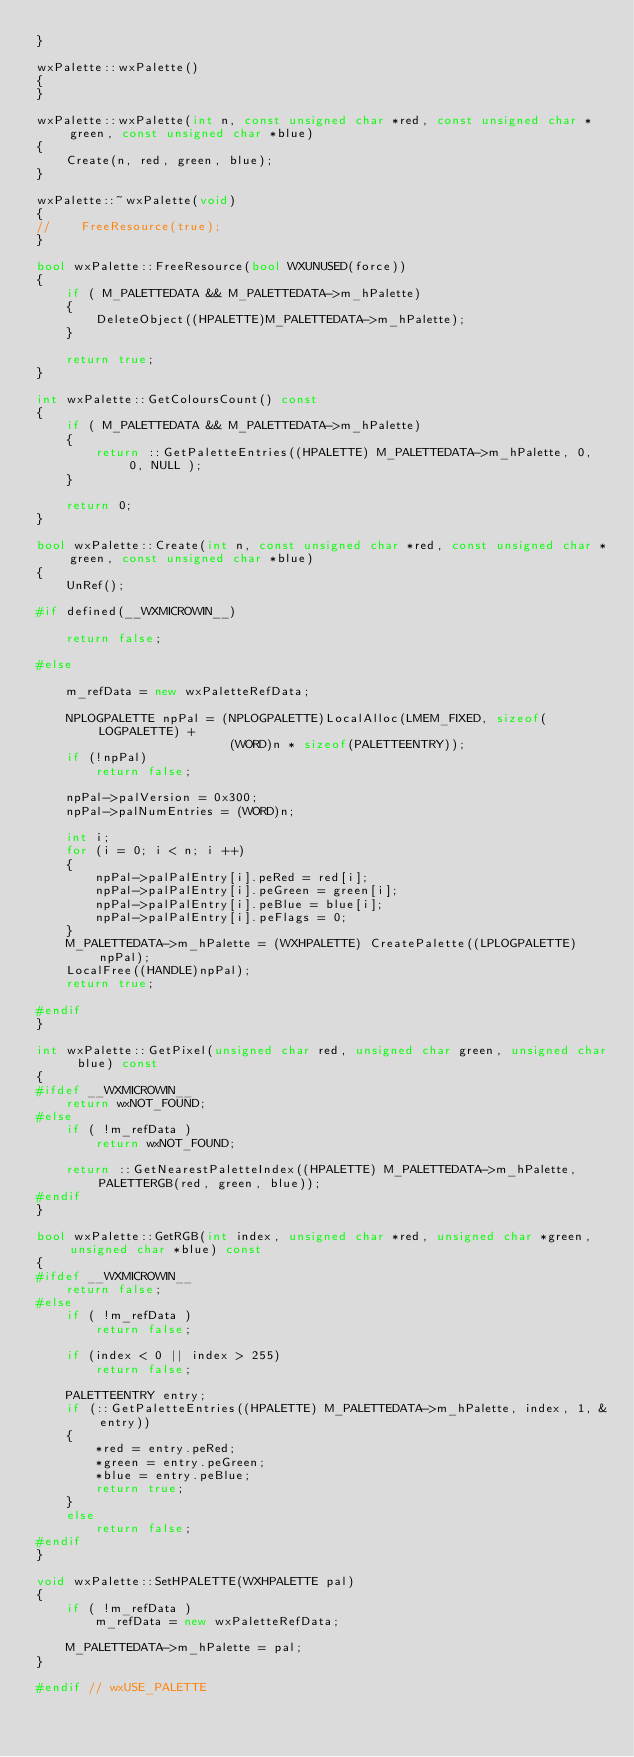<code> <loc_0><loc_0><loc_500><loc_500><_C++_>}

wxPalette::wxPalette()
{
}

wxPalette::wxPalette(int n, const unsigned char *red, const unsigned char *green, const unsigned char *blue)
{
    Create(n, red, green, blue);
}

wxPalette::~wxPalette(void)
{
//    FreeResource(true);
}

bool wxPalette::FreeResource(bool WXUNUSED(force))
{
    if ( M_PALETTEDATA && M_PALETTEDATA->m_hPalette)
    {
        DeleteObject((HPALETTE)M_PALETTEDATA->m_hPalette);
    }
    
    return true;
}

int wxPalette::GetColoursCount() const
{
    if ( M_PALETTEDATA && M_PALETTEDATA->m_hPalette)
    {
        return ::GetPaletteEntries((HPALETTE) M_PALETTEDATA->m_hPalette, 0, 0, NULL );
    }
    
    return 0;
}

bool wxPalette::Create(int n, const unsigned char *red, const unsigned char *green, const unsigned char *blue)
{
    UnRef();

#if defined(__WXMICROWIN__)

    return false;

#else

    m_refData = new wxPaletteRefData;

    NPLOGPALETTE npPal = (NPLOGPALETTE)LocalAlloc(LMEM_FIXED, sizeof(LOGPALETTE) +
                          (WORD)n * sizeof(PALETTEENTRY));
    if (!npPal)
        return false;

    npPal->palVersion = 0x300;
    npPal->palNumEntries = (WORD)n;

    int i;
    for (i = 0; i < n; i ++)
    {
        npPal->palPalEntry[i].peRed = red[i];
        npPal->palPalEntry[i].peGreen = green[i];
        npPal->palPalEntry[i].peBlue = blue[i];
        npPal->palPalEntry[i].peFlags = 0;
    }
    M_PALETTEDATA->m_hPalette = (WXHPALETTE) CreatePalette((LPLOGPALETTE)npPal);
    LocalFree((HANDLE)npPal);
    return true;

#endif
}

int wxPalette::GetPixel(unsigned char red, unsigned char green, unsigned char blue) const
{
#ifdef __WXMICROWIN__
    return wxNOT_FOUND;
#else
    if ( !m_refData )
        return wxNOT_FOUND;

    return ::GetNearestPaletteIndex((HPALETTE) M_PALETTEDATA->m_hPalette, PALETTERGB(red, green, blue));
#endif
}

bool wxPalette::GetRGB(int index, unsigned char *red, unsigned char *green, unsigned char *blue) const
{
#ifdef __WXMICROWIN__
    return false;
#else
    if ( !m_refData )
        return false;

    if (index < 0 || index > 255)
        return false;

    PALETTEENTRY entry;
    if (::GetPaletteEntries((HPALETTE) M_PALETTEDATA->m_hPalette, index, 1, &entry))
    {
        *red = entry.peRed;
        *green = entry.peGreen;
        *blue = entry.peBlue;
        return true;
    }
    else
        return false;
#endif
}

void wxPalette::SetHPALETTE(WXHPALETTE pal)
{
    if ( !m_refData )
        m_refData = new wxPaletteRefData;

    M_PALETTEDATA->m_hPalette = pal;
}

#endif // wxUSE_PALETTE
</code> 